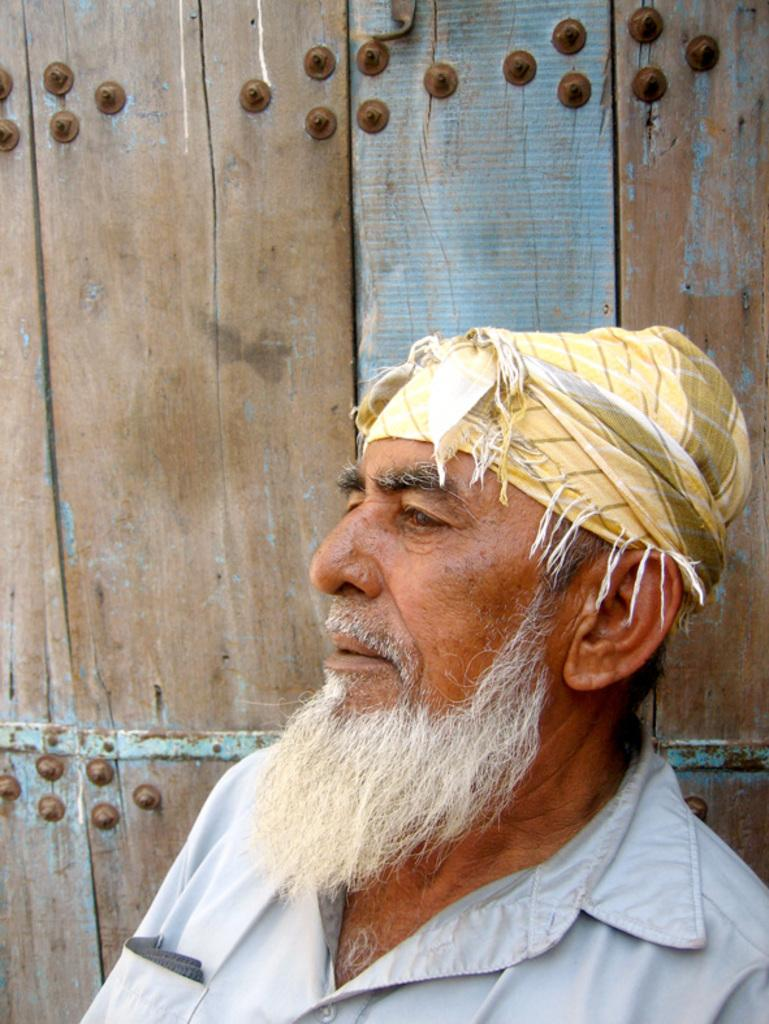Who is present in the image? There is a man in the image. What direction is the man looking in? The man is looking to the left. What can be seen in the background of the image? There is a wooden plank in the background of the image. What type of music is the man listening to in the image? There is no indication in the image that the man is listening to music, so it cannot be determined from the picture. 